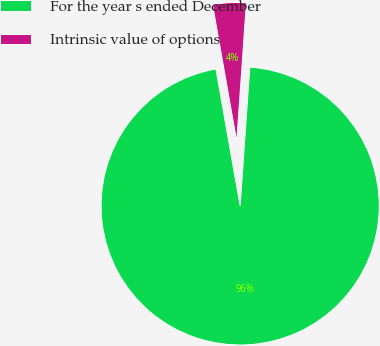Convert chart to OTSL. <chart><loc_0><loc_0><loc_500><loc_500><pie_chart><fcel>For the year s ended December<fcel>Intrinsic value of options<nl><fcel>96.11%<fcel>3.89%<nl></chart> 